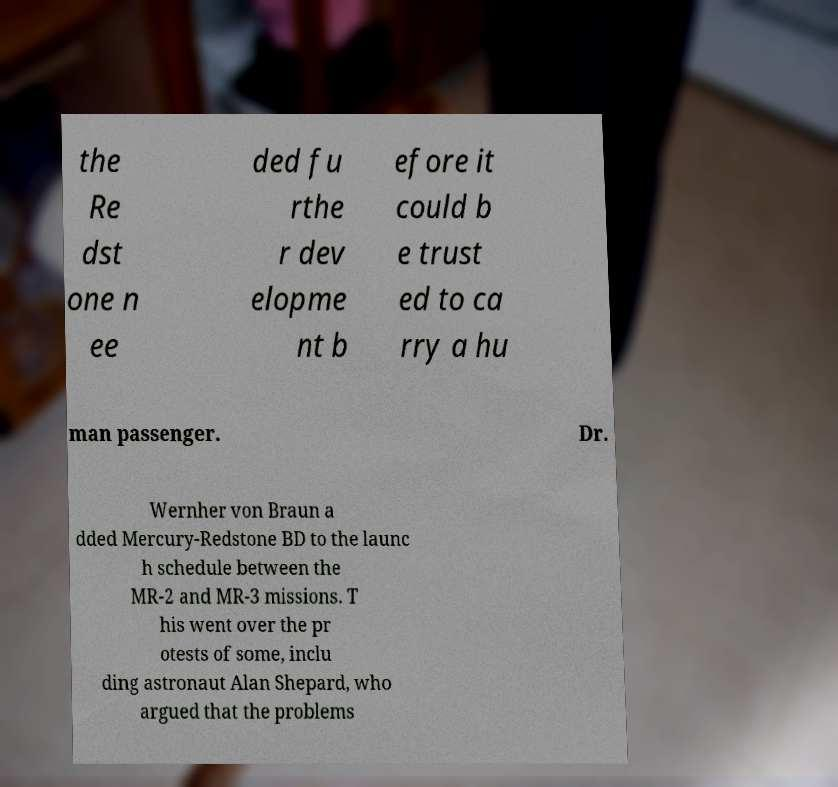Could you assist in decoding the text presented in this image and type it out clearly? the Re dst one n ee ded fu rthe r dev elopme nt b efore it could b e trust ed to ca rry a hu man passenger. Dr. Wernher von Braun a dded Mercury-Redstone BD to the launc h schedule between the MR-2 and MR-3 missions. T his went over the pr otests of some, inclu ding astronaut Alan Shepard, who argued that the problems 